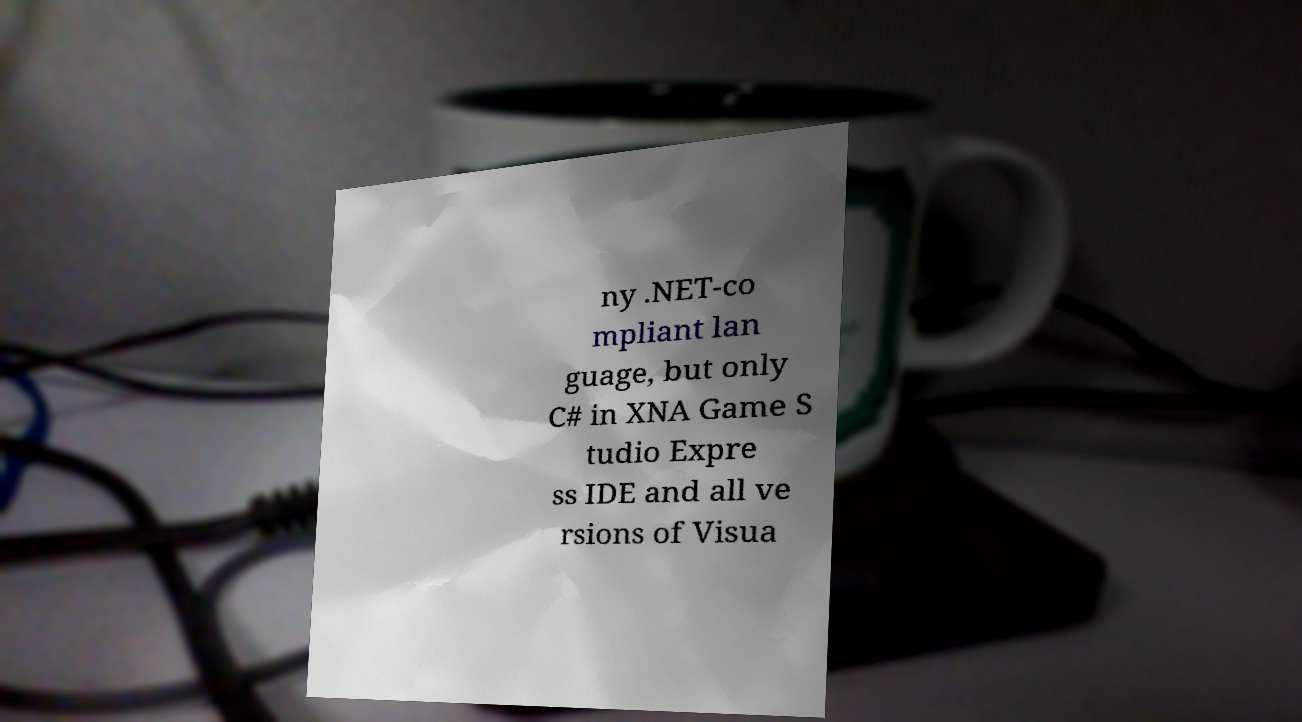I need the written content from this picture converted into text. Can you do that? ny .NET-co mpliant lan guage, but only C# in XNA Game S tudio Expre ss IDE and all ve rsions of Visua 